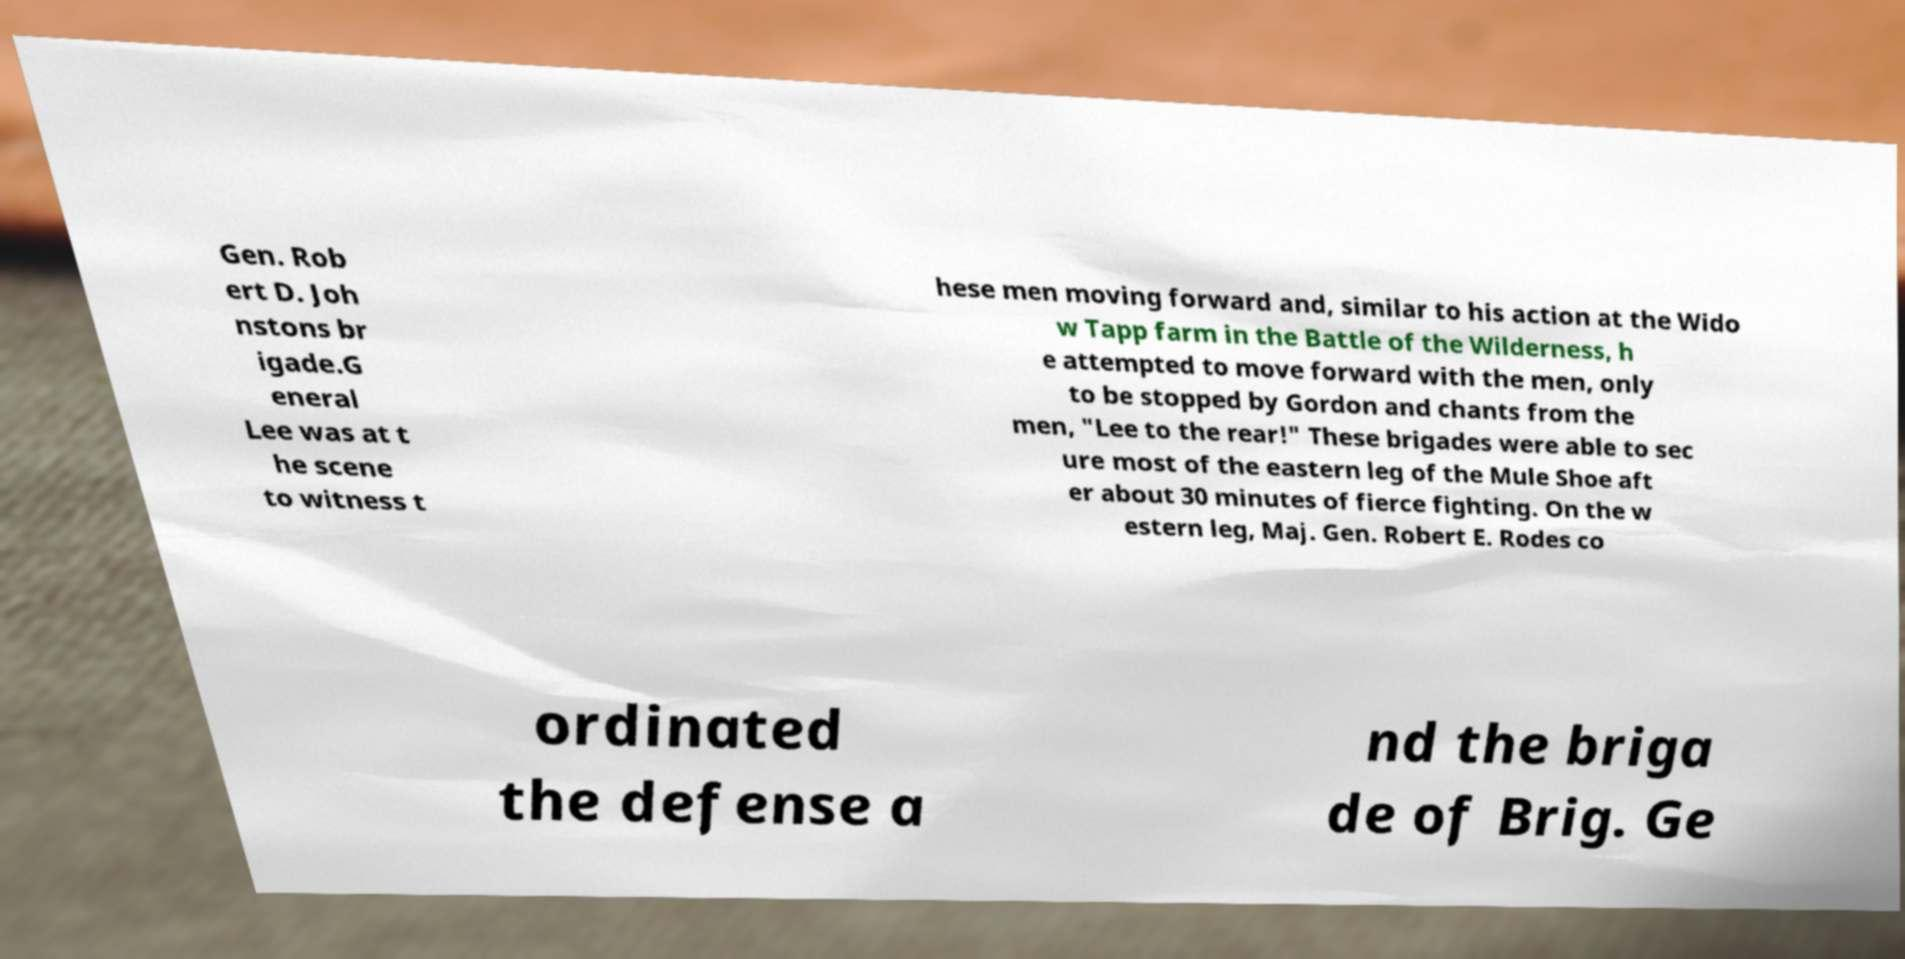Please read and relay the text visible in this image. What does it say? Gen. Rob ert D. Joh nstons br igade.G eneral Lee was at t he scene to witness t hese men moving forward and, similar to his action at the Wido w Tapp farm in the Battle of the Wilderness, h e attempted to move forward with the men, only to be stopped by Gordon and chants from the men, "Lee to the rear!" These brigades were able to sec ure most of the eastern leg of the Mule Shoe aft er about 30 minutes of fierce fighting. On the w estern leg, Maj. Gen. Robert E. Rodes co ordinated the defense a nd the briga de of Brig. Ge 